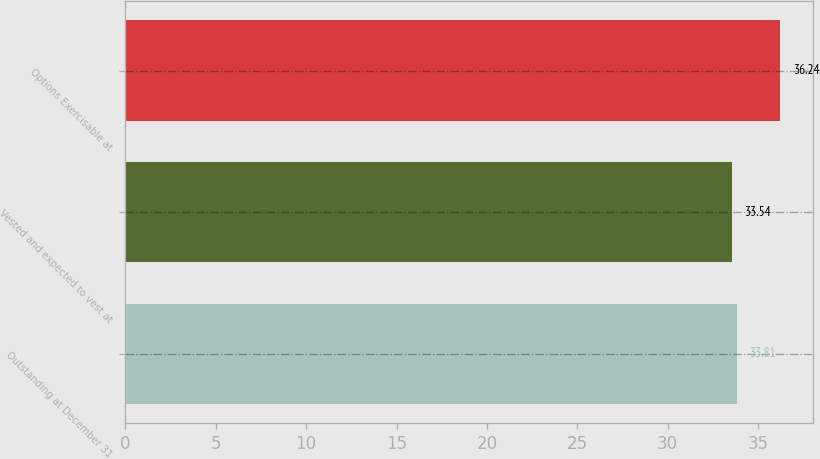<chart> <loc_0><loc_0><loc_500><loc_500><bar_chart><fcel>Outstanding at December 31<fcel>Vested and expected to vest at<fcel>Options Exercisable at<nl><fcel>33.81<fcel>33.54<fcel>36.24<nl></chart> 